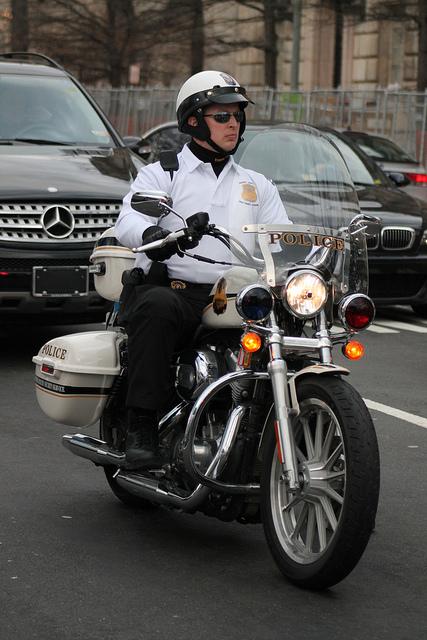What kind of bike is this?
Be succinct. Motorcycle. What color is the rider's jacket?
Answer briefly. White. Is that a cop?
Concise answer only. Yes. Is the motorcycle headlight on?
Short answer required. Yes. What is the last vehicle in the back?
Answer briefly. Car. 